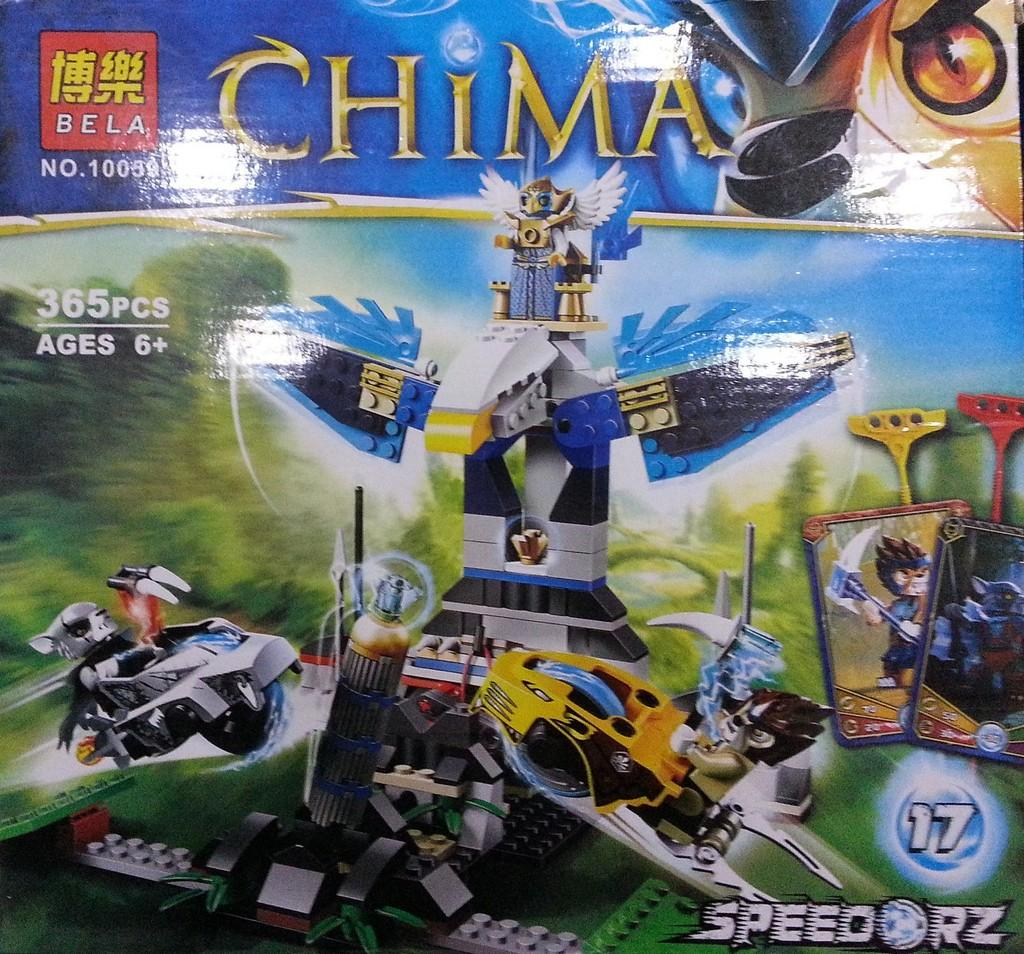What is featured in the image? There is a poster in the image. What can be seen on the poster? The poster contains images of machines. What additional information is provided on the poster? The word "China" is written on the poster. What type of bun can be seen in the image? There is no bun present in the image; it features a poster with images of machines and the word "China." 